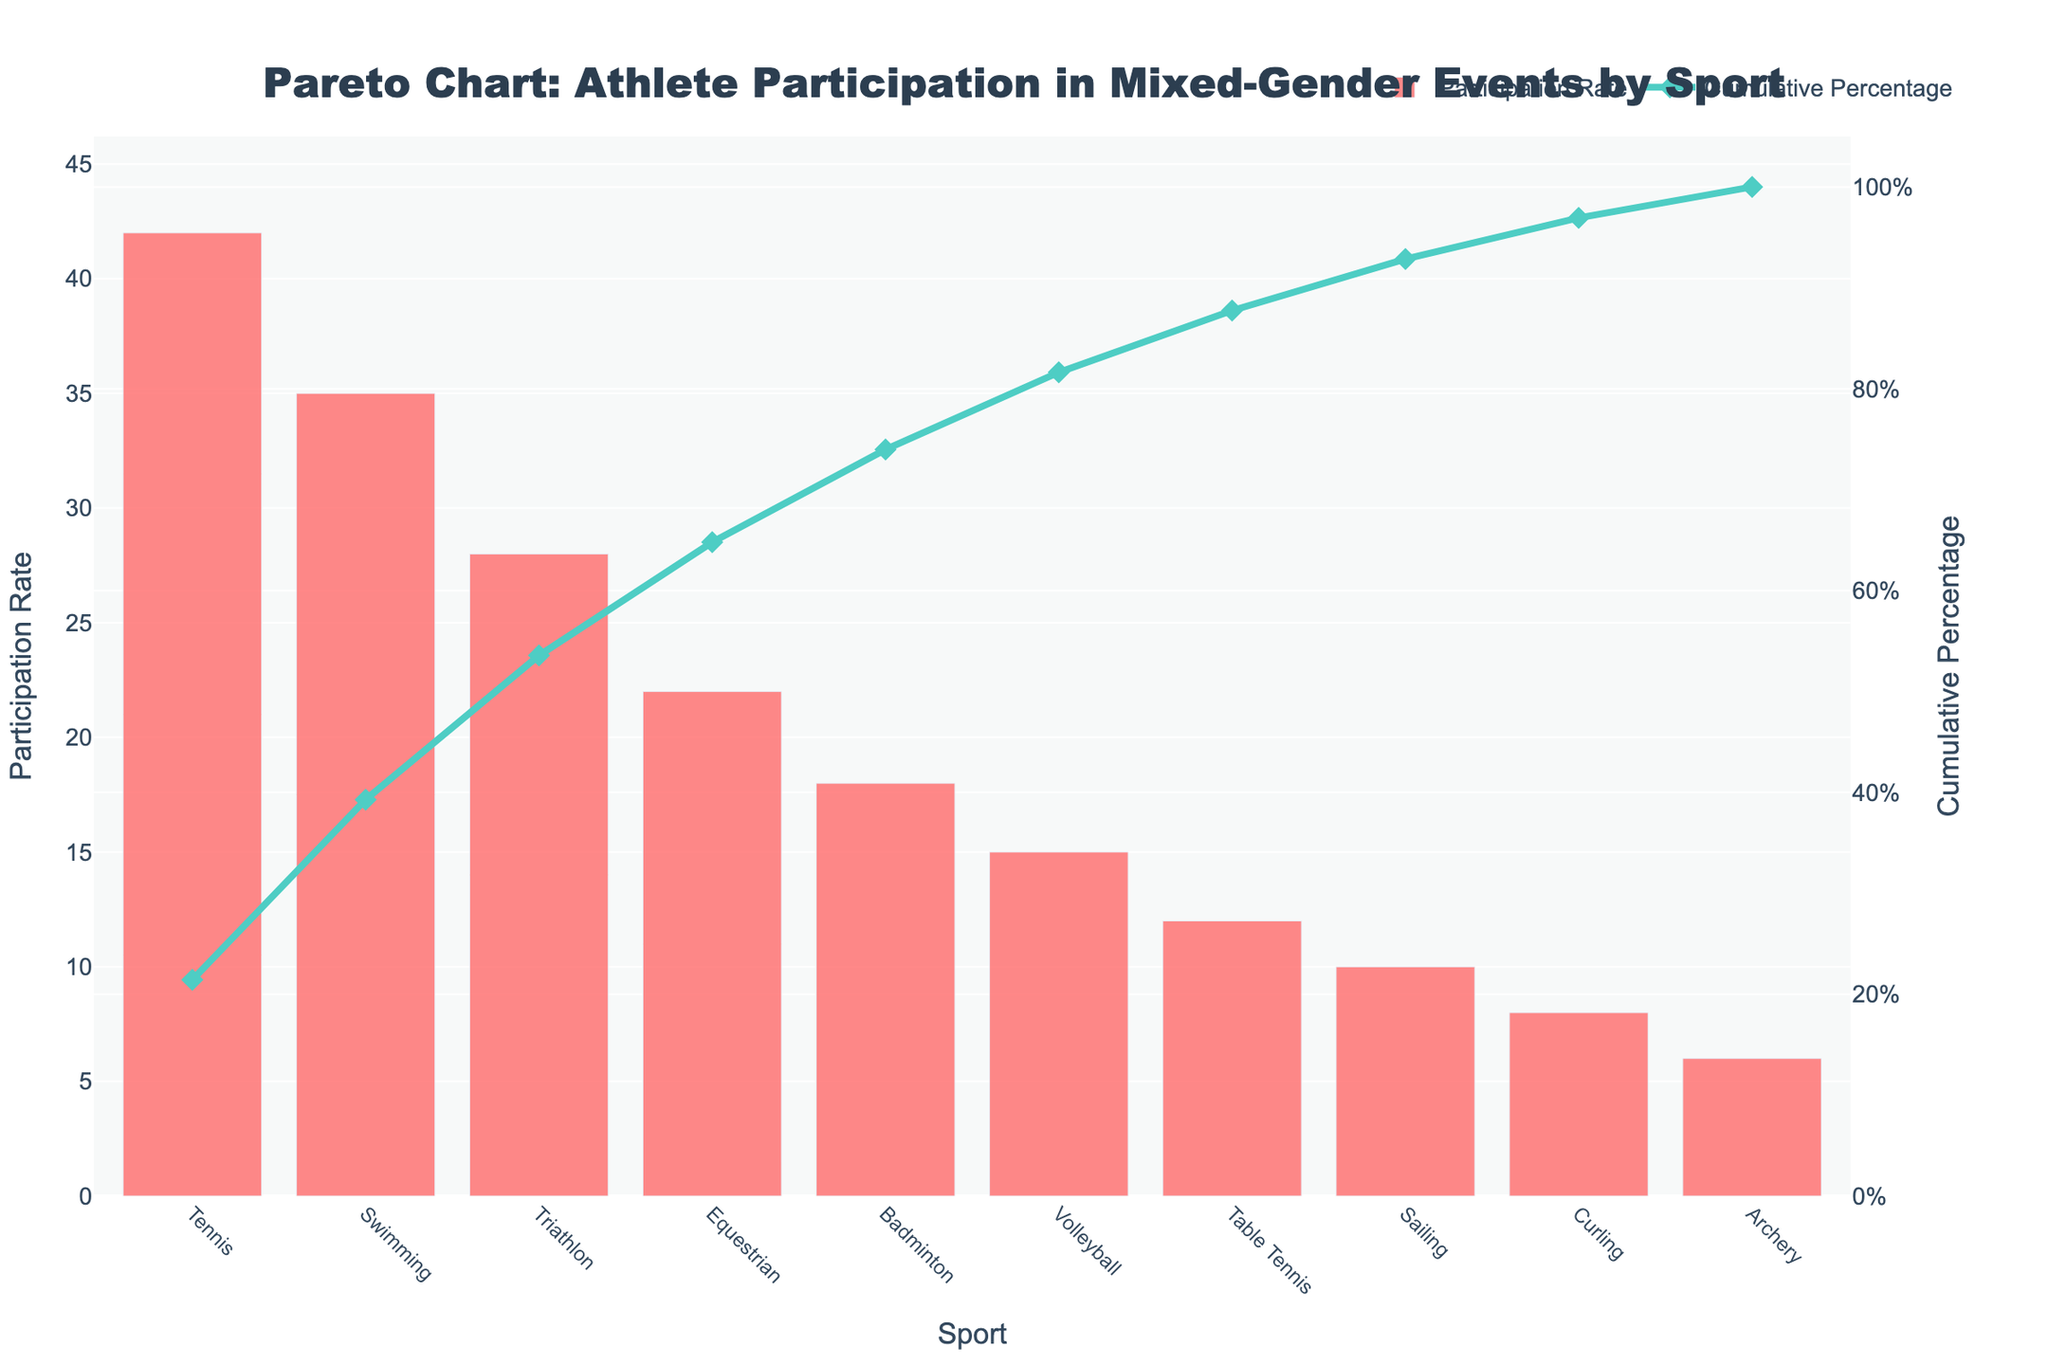What is the title of the figure? The title is located at the top of the figure, and it is designed to give an overview of what the chart is about. The text in the title is larger and bolder than other text elements.
Answer: Pareto Chart: Athlete Participation in Mixed-Gender Events by Sport Which sport has the highest participation rate? To determine the sport with the highest participation rate, look for the tallest bar in the chart. This bar corresponds to the sport with the highest value on the y-axis for Participation Rate.
Answer: Tennis What is the cumulative percentage at the sport of Table Tennis? To find this, locate the sport 'Table Tennis' on the x-axis and then look up to the corresponding point on the cumulative percentage line on the secondary y-axis.
Answer: 94% How many sports have a participation rate lower than 20%? Identify all bars whose height falls below the 20% mark on the y-axis that represents Participation Rate. Count these bars.
Answer: 5 What is the difference in participation rate between Swimming and Archery? Find the height of the bars for Swimming and Archery on the y-axis. Subtract the Participation Rate of Archery from that of Swimming.
Answer: 35 - 6 = 29 What cumulative percentage is reached by the fifth sport in the sorted order? Identify the fifth sport on the x-axis after sorting by descending participation rate. Look at the cumulative percentage line to find the value at this sport.
Answer: 79% Which two sports have the closest participation rates, and what is their rate? Examine the heights of the bars on the Participation Rate y-axis. Identify the two bars that are closest in height and note their common or nearly identical rates.
Answer: Curling and Sailing Does Volleyball contribute more than 10% to the cumulative percentage of athlete participation? Locate Volleyball on the x-axis, then follow up to the Cumulative Percentage line. Determine the value and see if it exceeds 10%.
Answer: Yes Which sport is exactly at the 50% cumulative percentage mark? Follow the Cumulative Percentage line to the 50% mark on the secondary y-axis. Trace this point down to see which sport it intersects on the x-axis.
Answer: Triathlon What is the average participation rate of the top three sports? Identify the participation rates of the top three sports based on their bars' heights. Sum these rates and divide by 3 to calculate the average.
Answer: (42 + 35 + 28) / 3 = 35 